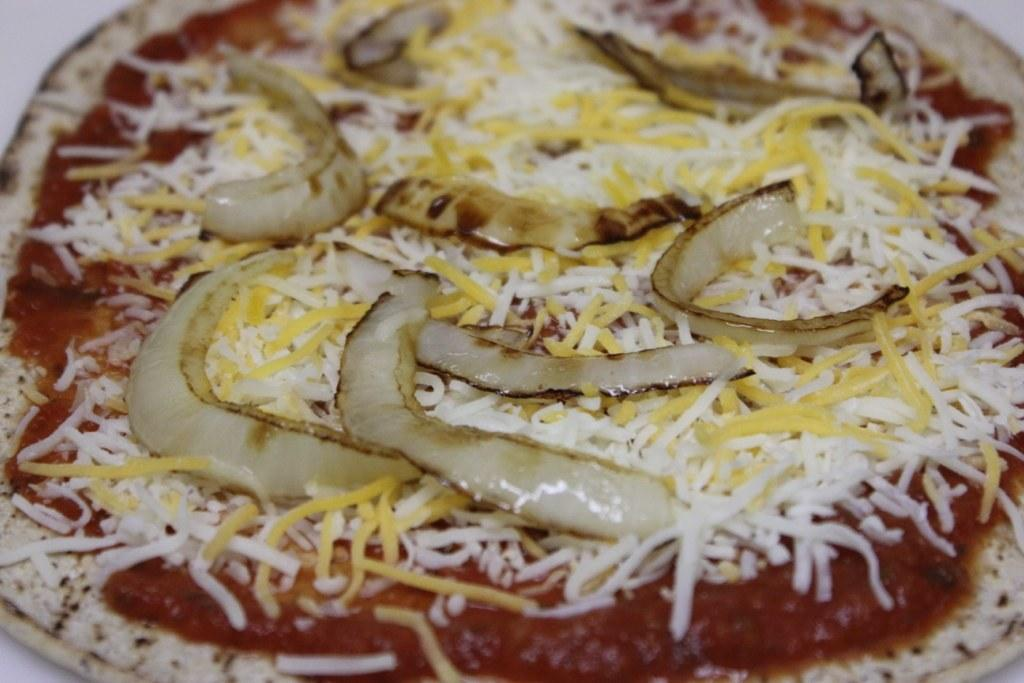What type of food can be seen in the image? There is bread in the image. What other ingredients are visible in the image? There are onion pieces and coconut pieces in the image. Where are these items located? The items are kept on a table. What type of nest can be seen in the image? There is no nest present in the image. How does the pig interact with the bread in the image? There is no pig present in the image. 